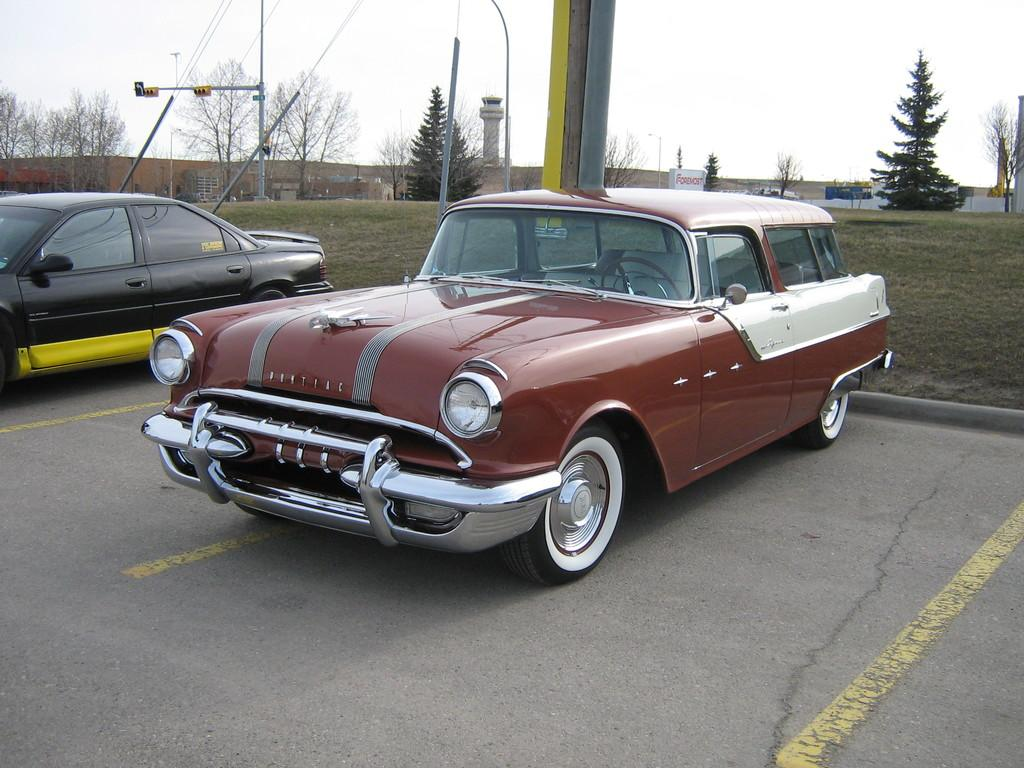How many cars are visible on the road in the image? There are two cars on the road in the image. What type of vegetation is present on the ground? There is grass on the ground in the image. What can be seen in the background of the image? There are trees and poles in the background of the image. What is visible at the top of the image? The sky is visible at the top of the image. How does the fact change the way we sort the cars in the image? There is no fact mentioned in the image, and the question of sorting the cars is not relevant to the image. 